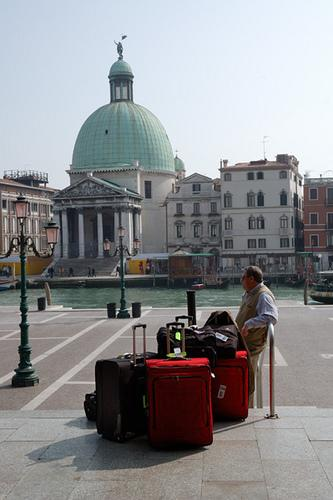What is this man enjoying here?

Choices:
A) sales job
B) beach
C) sleeping
D) vacation vacation 